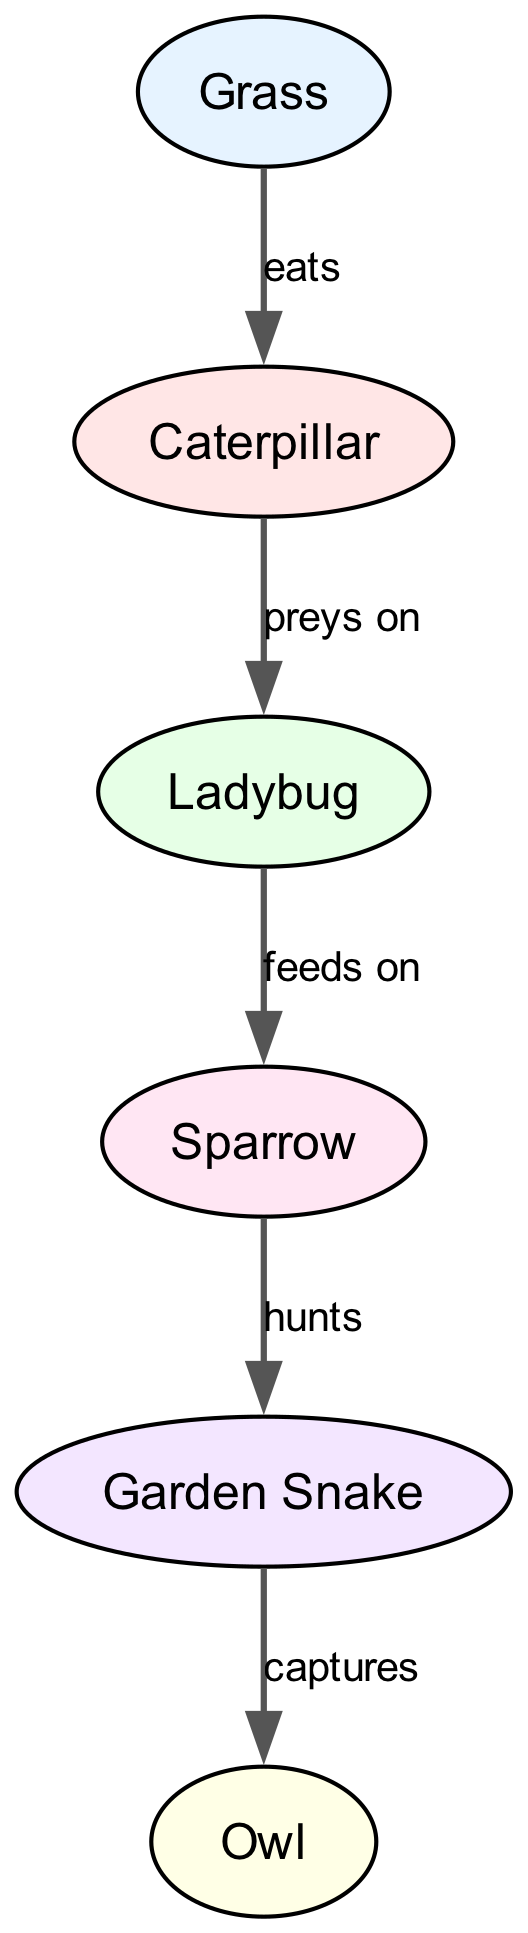What is the first organism in the food chain? The first organism is Grass, which is at the bottom of the food chain as a primary producer.
Answer: Grass How many nodes are present in the diagram? The nodes are: Grass, Caterpillar, Ladybug, Sparrow, Garden Snake, and Owl, totaling six nodes.
Answer: 6 Who preys on the Caterpillar? The organism that preys on the Caterpillar is the Ladybug, as indicated by the relation shown in the diagram.
Answer: Ladybug What does the Garden Snake do to the Sparrow? The Garden Snake hunts the Sparrow, as detailed by the action listed between the two in the relationships.
Answer: hunts Which organism is captured by the Owl? The organism captured by the Owl is the Garden Snake, as described in the relationships of the food chain.
Answer: Garden Snake How many direct consumers are there in the food chain? The direct consumers, which consume other organisms, are Caterpillar, Ladybug, Sparrow, Garden Snake, and Owl, totaling five consumers.
Answer: 5 Which organism is the primary producer? The primary producer in this food chain is Grass, serving as the initial source of energy for the other organisms.
Answer: Grass What action is associated with the relationship between Ladybug and Caterpillar? The action associated with the Ladybug and Caterpillar is "preys on", indicating the feeding relationship between these two organisms.
Answer: preys on Which organism is at the top of the food chain? The organism at the top of the food chain is the Owl, as it is the last in the sequence of consumers.
Answer: Owl 